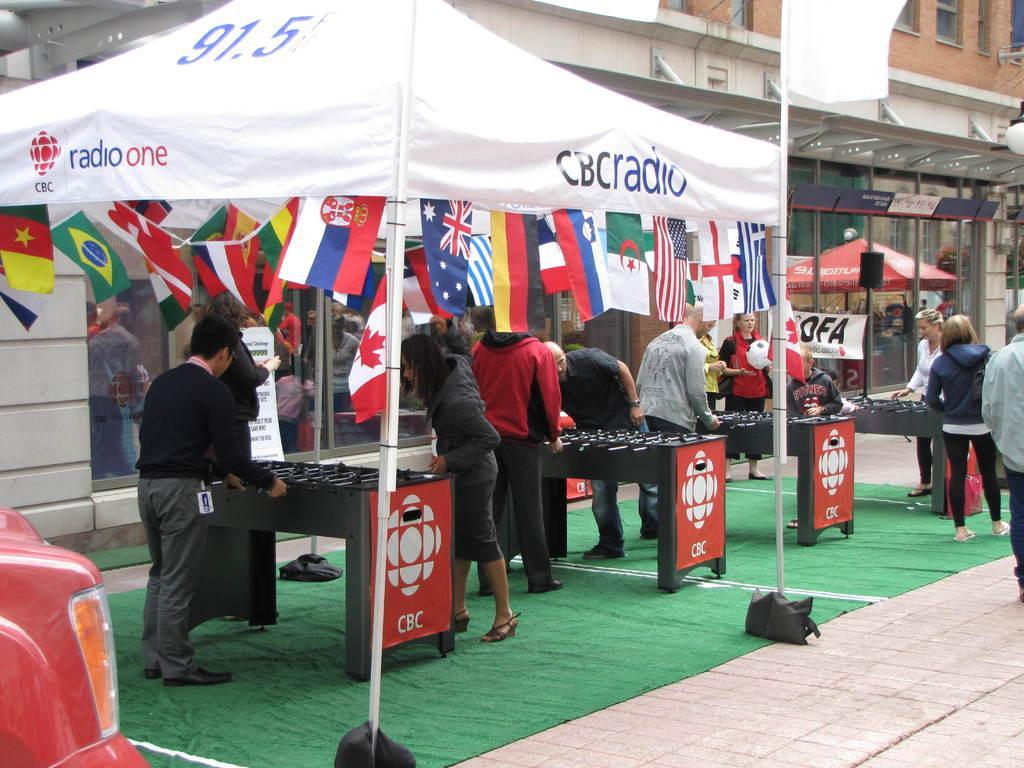In one or two sentences, can you explain what this image depicts? At the bottom left of the image there is a red car with light. Behind the car there are Foosball tables. Also there are few people playing Foosball game. Above them there is a white color tent with flags hanging to it. In the background there is a building with walls, windows, stores with glass doors. And on the floor there is a green carpet. 